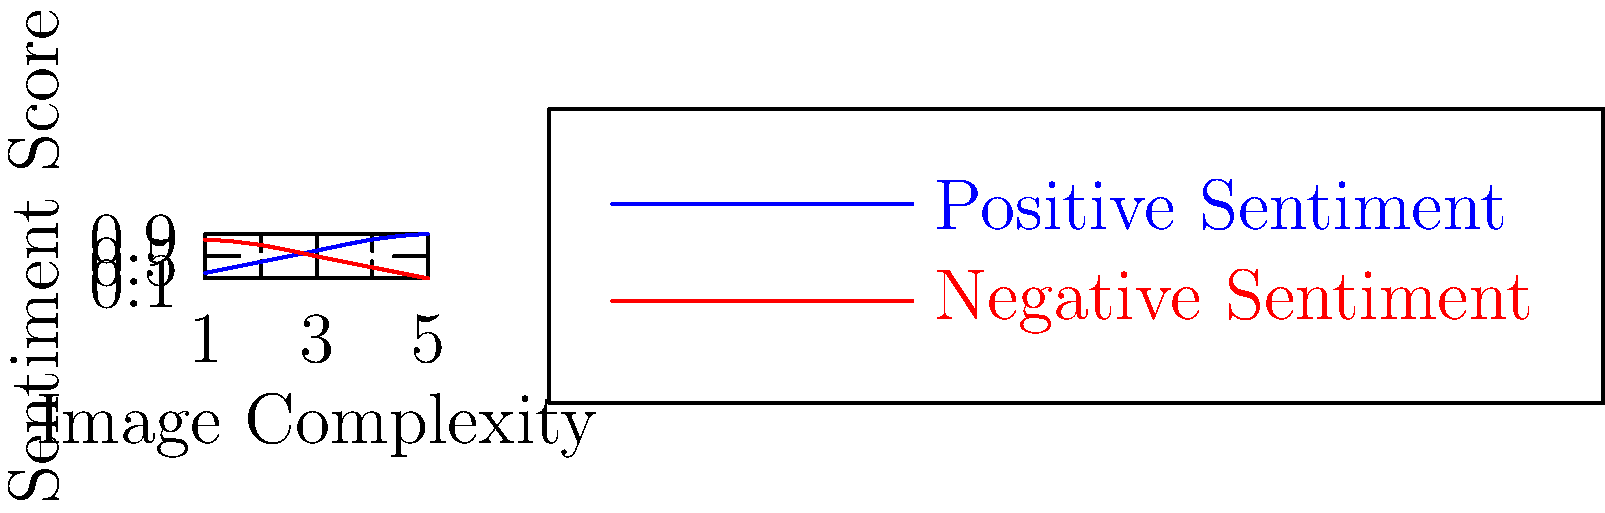In a political thriller documentary about media manipulation, you're analyzing the correlation between image complexity and sentiment scores for detecting fake news. The graph shows sentiment scores for positive and negative sentiments across increasing image complexity. What does this trend suggest about the effectiveness of using image sentiment analysis for fake news detection in complex political scenarios? To answer this question, let's analyze the graph step-by-step:

1. The x-axis represents image complexity, increasing from 1 to 5.
2. The y-axis represents sentiment scores, ranging from 0 to 1.
3. The blue line represents positive sentiment scores.
4. The red line represents negative sentiment scores.

Observing the trends:

5. As image complexity increases:
   a. Positive sentiment scores (blue line) increase from 0.2 to 0.9.
   b. Negative sentiment scores (red line) decrease from 0.8 to 0.1.

6. This inverse relationship suggests that:
   a. Simple images tend to have lower positive sentiment and higher negative sentiment.
   b. Complex images tend to have higher positive sentiment and lower negative sentiment.

7. In the context of fake news detection:
   a. The diverging trends imply that sentiment analysis becomes more polarized with complex images.
   b. This polarization could make it easier to distinguish between genuine and fake news for complex political scenarios.

8. However, this also suggests a potential limitation:
   a. Fake news creators might exploit this trend by using more complex images to artificially boost positive sentiment.
   b. Simple, negative images might be more easily flagged as potential fake news, even if they're genuine.

9. For political thrillers and documentaries:
   a. This trend highlights the sophistication of media manipulation techniques.
   b. It emphasizes the need for multi-faceted approaches to fake news detection, beyond just image sentiment analysis.
Answer: The trend suggests increased polarization of sentiment scores with image complexity, potentially improving fake news detection but also revealing vulnerabilities to manipulation in complex political scenarios. 